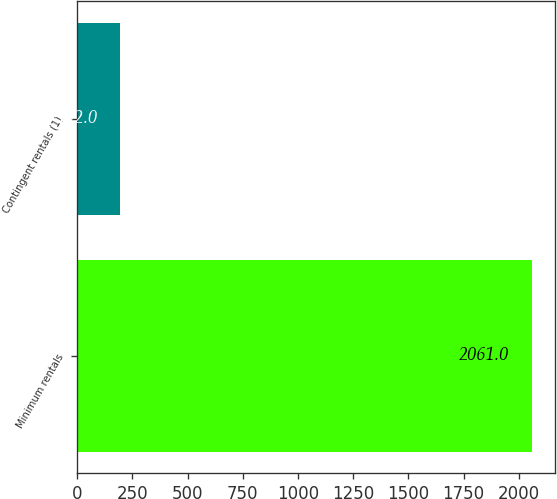<chart> <loc_0><loc_0><loc_500><loc_500><bar_chart><fcel>Minimum rentals<fcel>Contingent rentals (1)<nl><fcel>2061<fcel>192<nl></chart> 